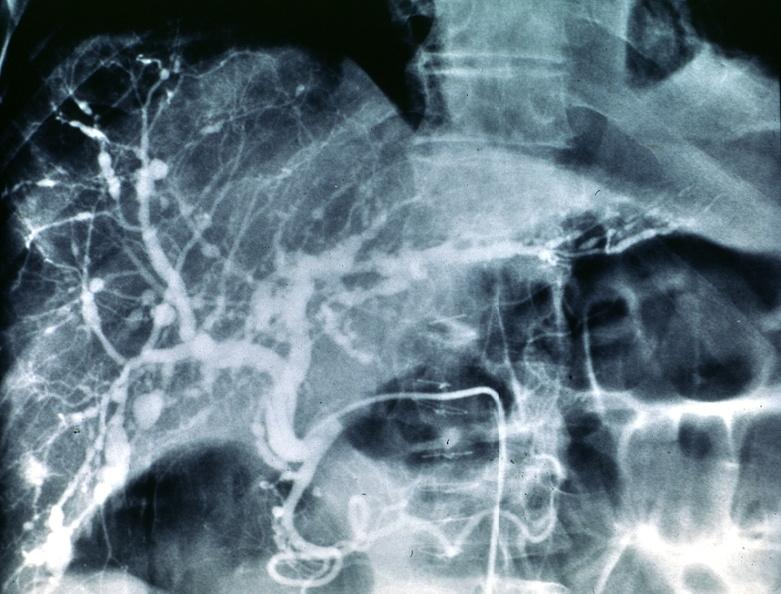what is present?
Answer the question using a single word or phrase. Hepatobiliary 